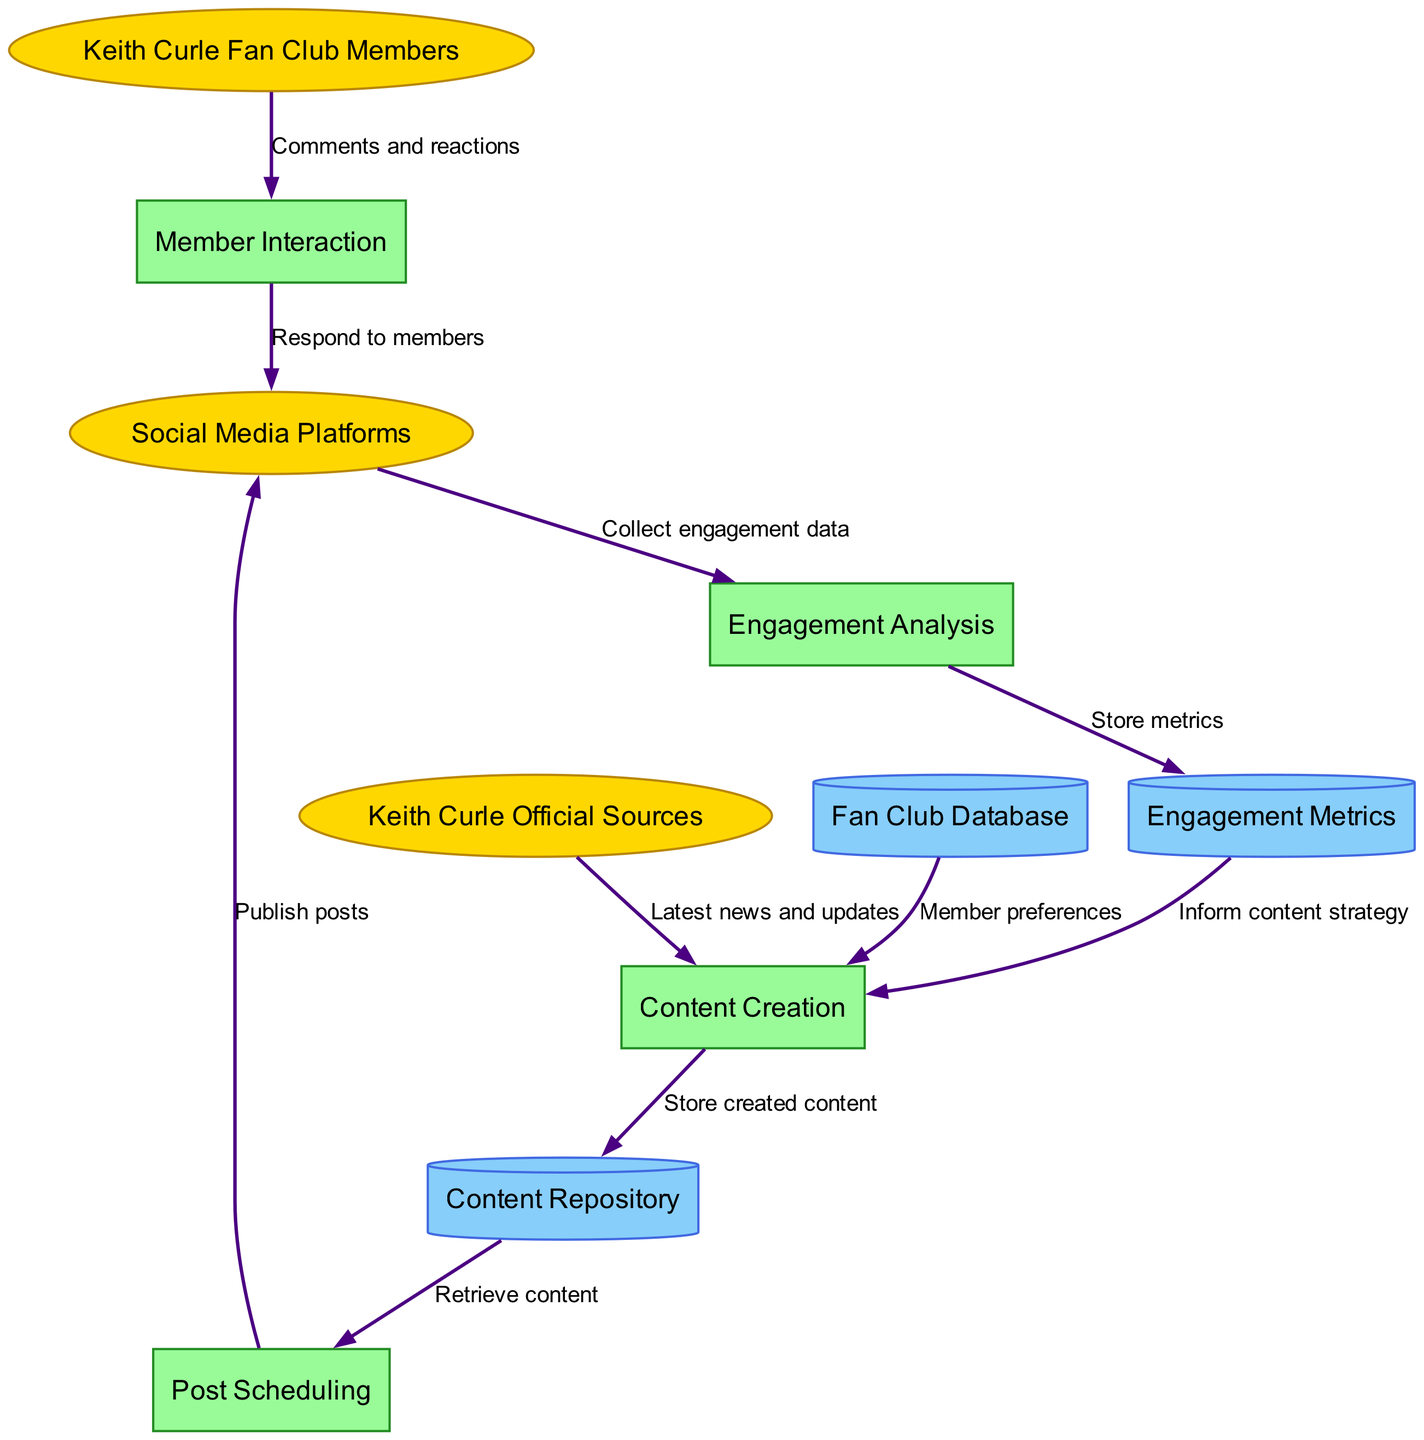What are the external entities in the diagram? The diagram shows three external entities: "Keith Curle Fan Club Members," "Keith Curle Official Sources," and "Social Media Platforms."
Answer: Keith Curle Fan Club Members, Keith Curle Official Sources, Social Media Platforms How many processes are depicted in the diagram? The diagram lists four processes: "Content Creation," "Post Scheduling," "Member Interaction," and "Engagement Analysis." Therefore, there are a total of four processes.
Answer: 4 What data flow starts from the 'Content Creation' process? From the 'Content Creation' process, there is a flow labeled "Store created content," which goes to the 'Content Repository.'
Answer: Store created content Which data store is used to inform content strategy in the diagram? The flow from 'Engagement Metrics' to 'Content Creation' is labeled "Inform content strategy," indicating that 'Engagement Metrics' is the relevant data store for this purpose.
Answer: Engagement Metrics What do fan club members provide in the member interaction process? The data flow from "Keith Curle Fan Club Members" to "Member Interaction" is labeled "Comments and reactions," indicating that members contribute their comments and reactions.
Answer: Comments and reactions Which external entity provides the latest news and updates? The data flow from "Keith Curle Official Sources" to "Content Creation" is labeled "Latest news and updates," meaning this external entity is responsible for providing that information.
Answer: Keith Curle Official Sources What type of data is collected in the engagement analysis process? The engagement analysis process collects engagement data from the "Social Media Platforms." This information is essential for the analysis of member engagement.
Answer: Engagement data What is the flow that retrieves content from the content repository? The flow is labeled "Retrieve content," which is directed towards the 'Post Scheduling' process, showing that this process retrieves content for scheduling.
Answer: Retrieve content What information does the 'Fan Club Database' provide to content creation? The flow labeled "Member preferences" shows that the 'Fan Club Database' supplies member preferences to the 'Content Creation' process.
Answer: Member preferences 